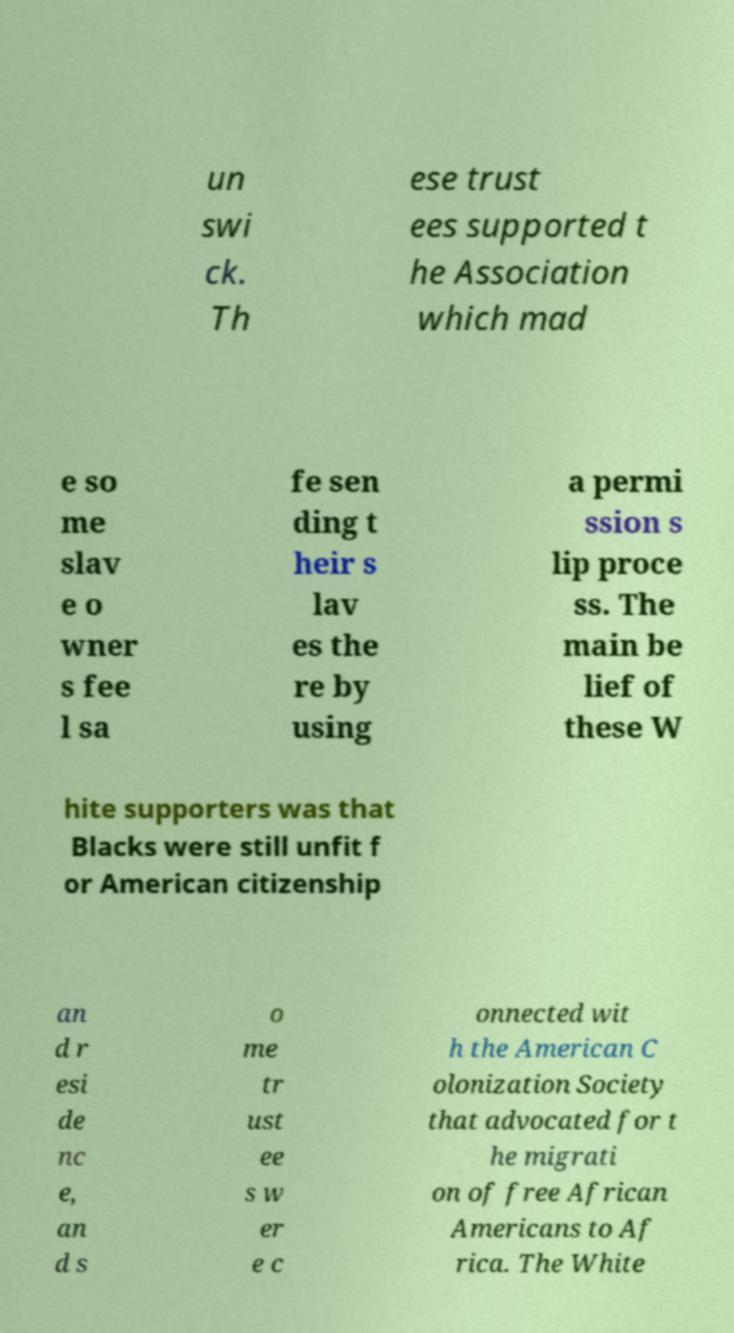I need the written content from this picture converted into text. Can you do that? un swi ck. Th ese trust ees supported t he Association which mad e so me slav e o wner s fee l sa fe sen ding t heir s lav es the re by using a permi ssion s lip proce ss. The main be lief of these W hite supporters was that Blacks were still unfit f or American citizenship an d r esi de nc e, an d s o me tr ust ee s w er e c onnected wit h the American C olonization Society that advocated for t he migrati on of free African Americans to Af rica. The White 